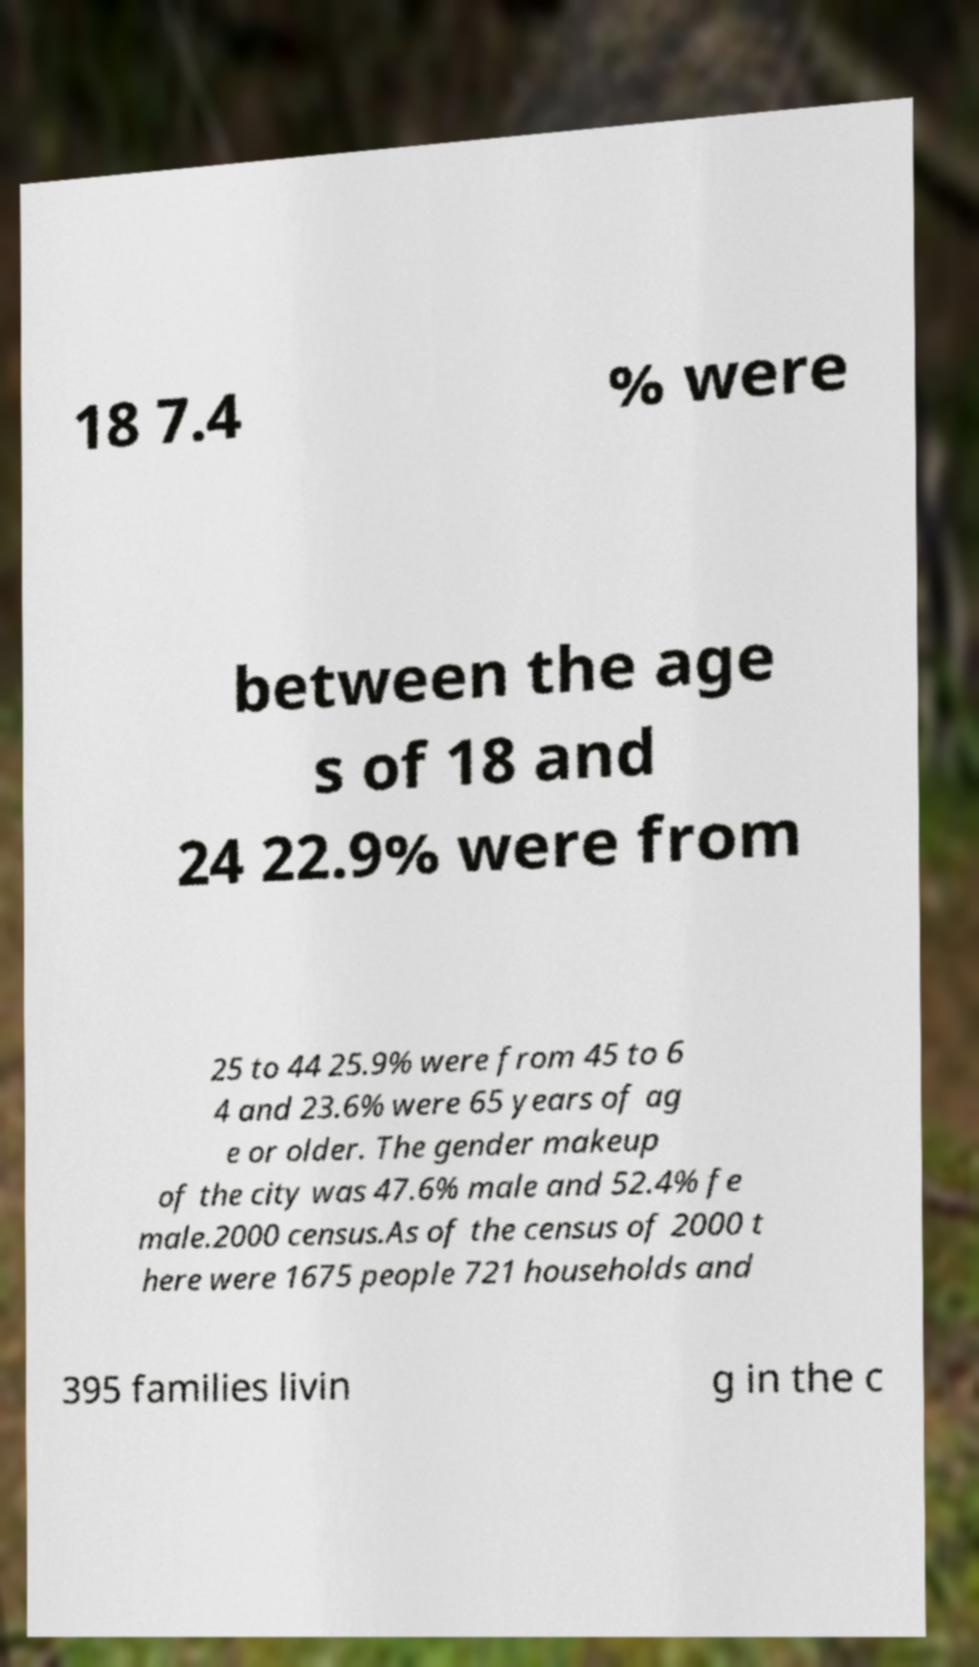For documentation purposes, I need the text within this image transcribed. Could you provide that? 18 7.4 % were between the age s of 18 and 24 22.9% were from 25 to 44 25.9% were from 45 to 6 4 and 23.6% were 65 years of ag e or older. The gender makeup of the city was 47.6% male and 52.4% fe male.2000 census.As of the census of 2000 t here were 1675 people 721 households and 395 families livin g in the c 